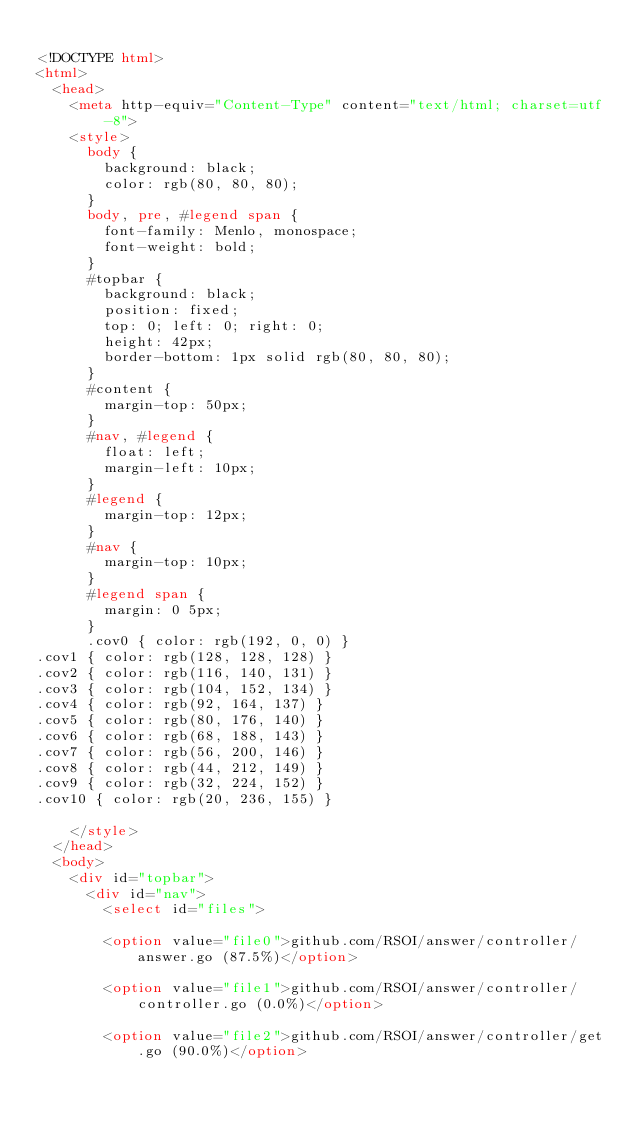Convert code to text. <code><loc_0><loc_0><loc_500><loc_500><_HTML_>
<!DOCTYPE html>
<html>
	<head>
		<meta http-equiv="Content-Type" content="text/html; charset=utf-8">
		<style>
			body {
				background: black;
				color: rgb(80, 80, 80);
			}
			body, pre, #legend span {
				font-family: Menlo, monospace;
				font-weight: bold;
			}
			#topbar {
				background: black;
				position: fixed;
				top: 0; left: 0; right: 0;
				height: 42px;
				border-bottom: 1px solid rgb(80, 80, 80);
			}
			#content {
				margin-top: 50px;
			}
			#nav, #legend {
				float: left;
				margin-left: 10px;
			}
			#legend {
				margin-top: 12px;
			}
			#nav {
				margin-top: 10px;
			}
			#legend span {
				margin: 0 5px;
			}
			.cov0 { color: rgb(192, 0, 0) }
.cov1 { color: rgb(128, 128, 128) }
.cov2 { color: rgb(116, 140, 131) }
.cov3 { color: rgb(104, 152, 134) }
.cov4 { color: rgb(92, 164, 137) }
.cov5 { color: rgb(80, 176, 140) }
.cov6 { color: rgb(68, 188, 143) }
.cov7 { color: rgb(56, 200, 146) }
.cov8 { color: rgb(44, 212, 149) }
.cov9 { color: rgb(32, 224, 152) }
.cov10 { color: rgb(20, 236, 155) }

		</style>
	</head>
	<body>
		<div id="topbar">
			<div id="nav">
				<select id="files">
				
				<option value="file0">github.com/RSOI/answer/controller/answer.go (87.5%)</option>
				
				<option value="file1">github.com/RSOI/answer/controller/controller.go (0.0%)</option>
				
				<option value="file2">github.com/RSOI/answer/controller/get.go (90.0%)</option>
				</code> 